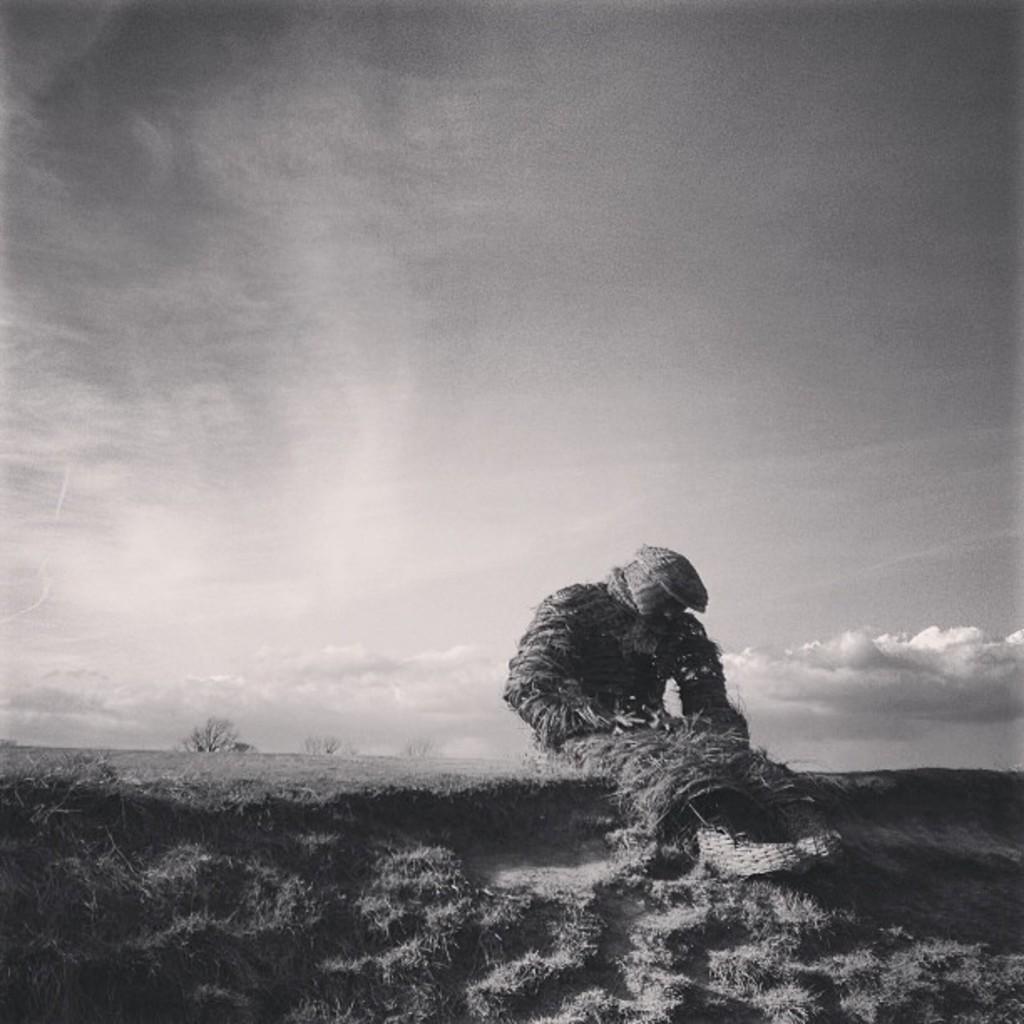Can you describe this image briefly? This is a black and white image. I think this is the straw man. Here is the grass. In the background, I can see the tree. These are the clouds in the sky. 